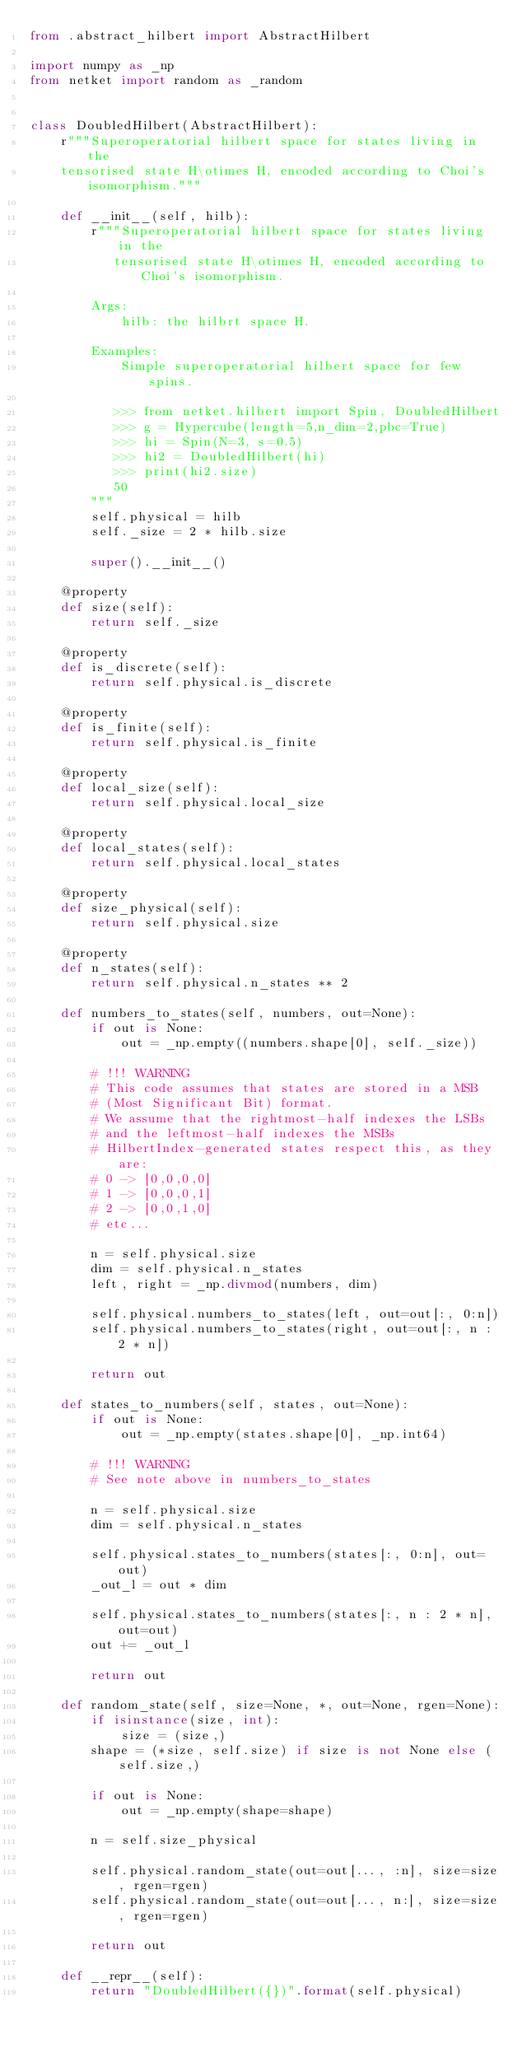<code> <loc_0><loc_0><loc_500><loc_500><_Python_>from .abstract_hilbert import AbstractHilbert

import numpy as _np
from netket import random as _random


class DoubledHilbert(AbstractHilbert):
    r"""Superoperatorial hilbert space for states living in the
    tensorised state H\otimes H, encoded according to Choi's isomorphism."""

    def __init__(self, hilb):
        r"""Superoperatorial hilbert space for states living in the
           tensorised state H\otimes H, encoded according to Choi's isomorphism.

        Args:
            hilb: the hilbrt space H.

        Examples:
            Simple superoperatorial hilbert space for few spins.

           >>> from netket.hilbert import Spin, DoubledHilbert
           >>> g = Hypercube(length=5,n_dim=2,pbc=True)
           >>> hi = Spin(N=3, s=0.5)
           >>> hi2 = DoubledHilbert(hi)
           >>> print(hi2.size)
           50
        """
        self.physical = hilb
        self._size = 2 * hilb.size

        super().__init__()

    @property
    def size(self):
        return self._size

    @property
    def is_discrete(self):
        return self.physical.is_discrete

    @property
    def is_finite(self):
        return self.physical.is_finite

    @property
    def local_size(self):
        return self.physical.local_size

    @property
    def local_states(self):
        return self.physical.local_states

    @property
    def size_physical(self):
        return self.physical.size

    @property
    def n_states(self):
        return self.physical.n_states ** 2

    def numbers_to_states(self, numbers, out=None):
        if out is None:
            out = _np.empty((numbers.shape[0], self._size))

        # !!! WARNING
        # This code assumes that states are stored in a MSB
        # (Most Significant Bit) format.
        # We assume that the rightmost-half indexes the LSBs
        # and the leftmost-half indexes the MSBs
        # HilbertIndex-generated states respect this, as they are:
        # 0 -> [0,0,0,0]
        # 1 -> [0,0,0,1]
        # 2 -> [0,0,1,0]
        # etc...

        n = self.physical.size
        dim = self.physical.n_states
        left, right = _np.divmod(numbers, dim)

        self.physical.numbers_to_states(left, out=out[:, 0:n])
        self.physical.numbers_to_states(right, out=out[:, n : 2 * n])

        return out

    def states_to_numbers(self, states, out=None):
        if out is None:
            out = _np.empty(states.shape[0], _np.int64)

        # !!! WARNING
        # See note above in numbers_to_states

        n = self.physical.size
        dim = self.physical.n_states

        self.physical.states_to_numbers(states[:, 0:n], out=out)
        _out_l = out * dim

        self.physical.states_to_numbers(states[:, n : 2 * n], out=out)
        out += _out_l

        return out

    def random_state(self, size=None, *, out=None, rgen=None):
        if isinstance(size, int):
            size = (size,)
        shape = (*size, self.size) if size is not None else (self.size,)

        if out is None:
            out = _np.empty(shape=shape)

        n = self.size_physical

        self.physical.random_state(out=out[..., :n], size=size, rgen=rgen)
        self.physical.random_state(out=out[..., n:], size=size, rgen=rgen)

        return out

    def __repr__(self):
        return "DoubledHilbert({})".format(self.physical)
</code> 